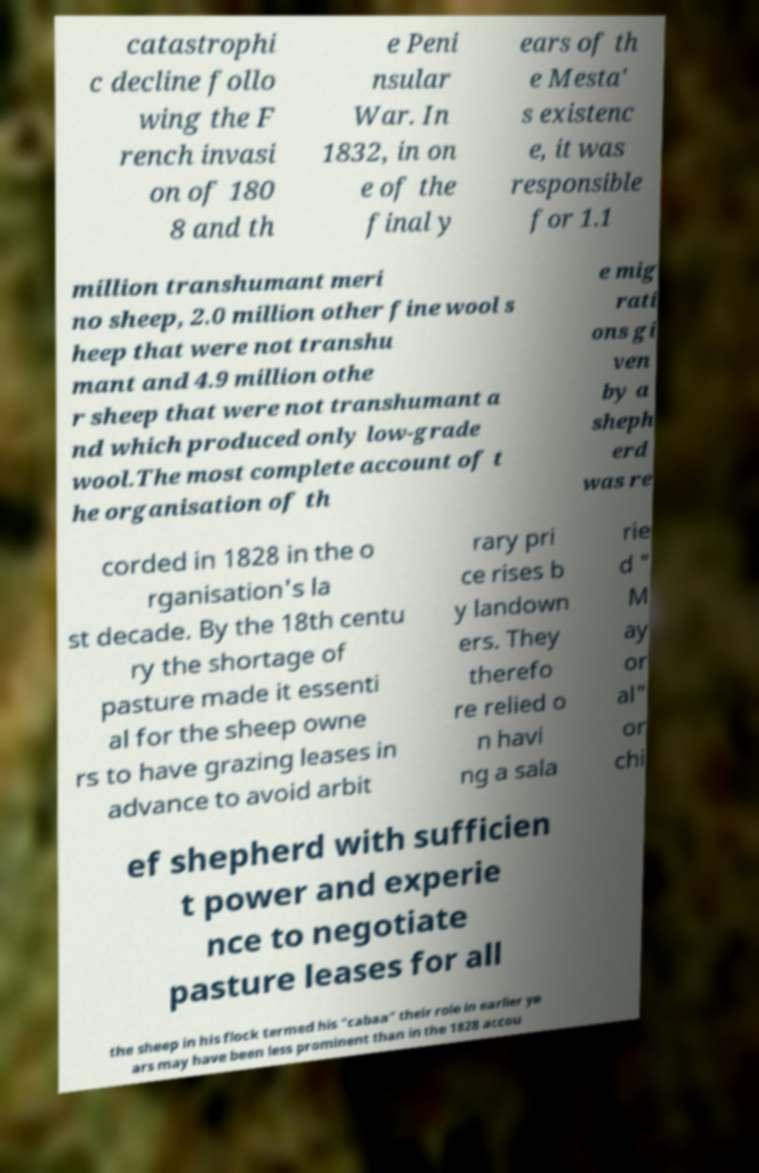Please identify and transcribe the text found in this image. catastrophi c decline follo wing the F rench invasi on of 180 8 and th e Peni nsular War. In 1832, in on e of the final y ears of th e Mesta' s existenc e, it was responsible for 1.1 million transhumant meri no sheep, 2.0 million other fine wool s heep that were not transhu mant and 4.9 million othe r sheep that were not transhumant a nd which produced only low-grade wool.The most complete account of t he organisation of th e mig rati ons gi ven by a sheph erd was re corded in 1828 in the o rganisation's la st decade. By the 18th centu ry the shortage of pasture made it essenti al for the sheep owne rs to have grazing leases in advance to avoid arbit rary pri ce rises b y landown ers. They therefo re relied o n havi ng a sala rie d " M ay or al" or chi ef shepherd with sufficien t power and experie nce to negotiate pasture leases for all the sheep in his flock termed his "cabaa" their role in earlier ye ars may have been less prominent than in the 1828 accou 